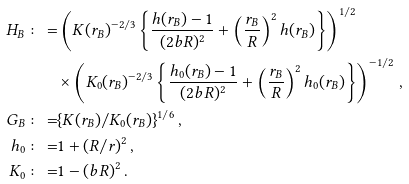<formula> <loc_0><loc_0><loc_500><loc_500>H _ { B } \colon = & \left ( K ( r _ { B } ) ^ { - 2 / 3 } \left \{ \frac { h ( r _ { B } ) - 1 } { ( 2 b R ) ^ { 2 } } + \left ( \frac { r _ { B } } { R } \right ) ^ { 2 } h ( r _ { B } ) \right \} \right ) ^ { 1 / 2 } \\ & \times \left ( K _ { 0 } ( r _ { B } ) ^ { - 2 / 3 } \left \{ \frac { h _ { 0 } ( r _ { B } ) - 1 } { ( 2 b R ) ^ { 2 } } + \left ( \frac { r _ { B } } { R } \right ) ^ { 2 } h _ { 0 } ( r _ { B } ) \right \} \right ) ^ { - 1 / 2 } \, , \\ G _ { B } \colon = & \{ K ( r _ { B } ) / K _ { 0 } ( r _ { B } ) \} ^ { 1 / 6 } \, , \\ h _ { 0 } \colon = & 1 + ( R / r ) ^ { 2 } \, , \\ K _ { 0 } \colon = & 1 - ( b R ) ^ { 2 } \, .</formula> 